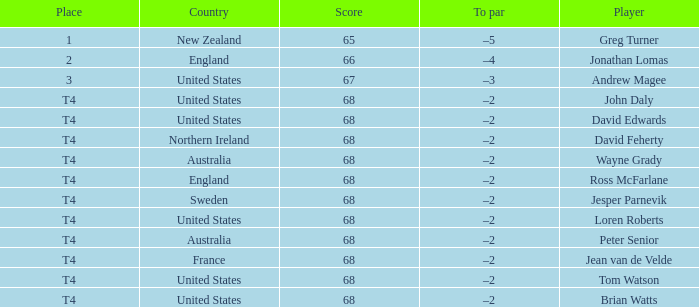Parse the table in full. {'header': ['Place', 'Country', 'Score', 'To par', 'Player'], 'rows': [['1', 'New Zealand', '65', '–5', 'Greg Turner'], ['2', 'England', '66', '–4', 'Jonathan Lomas'], ['3', 'United States', '67', '–3', 'Andrew Magee'], ['T4', 'United States', '68', '–2', 'John Daly'], ['T4', 'United States', '68', '–2', 'David Edwards'], ['T4', 'Northern Ireland', '68', '–2', 'David Feherty'], ['T4', 'Australia', '68', '–2', 'Wayne Grady'], ['T4', 'England', '68', '–2', 'Ross McFarlane'], ['T4', 'Sweden', '68', '–2', 'Jesper Parnevik'], ['T4', 'United States', '68', '–2', 'Loren Roberts'], ['T4', 'Australia', '68', '–2', 'Peter Senior'], ['T4', 'France', '68', '–2', 'Jean van de Velde'], ['T4', 'United States', '68', '–2', 'Tom Watson'], ['T4', 'United States', '68', '–2', 'Brian Watts']]} Name the Score united states of tom watson in united state? 68.0. 